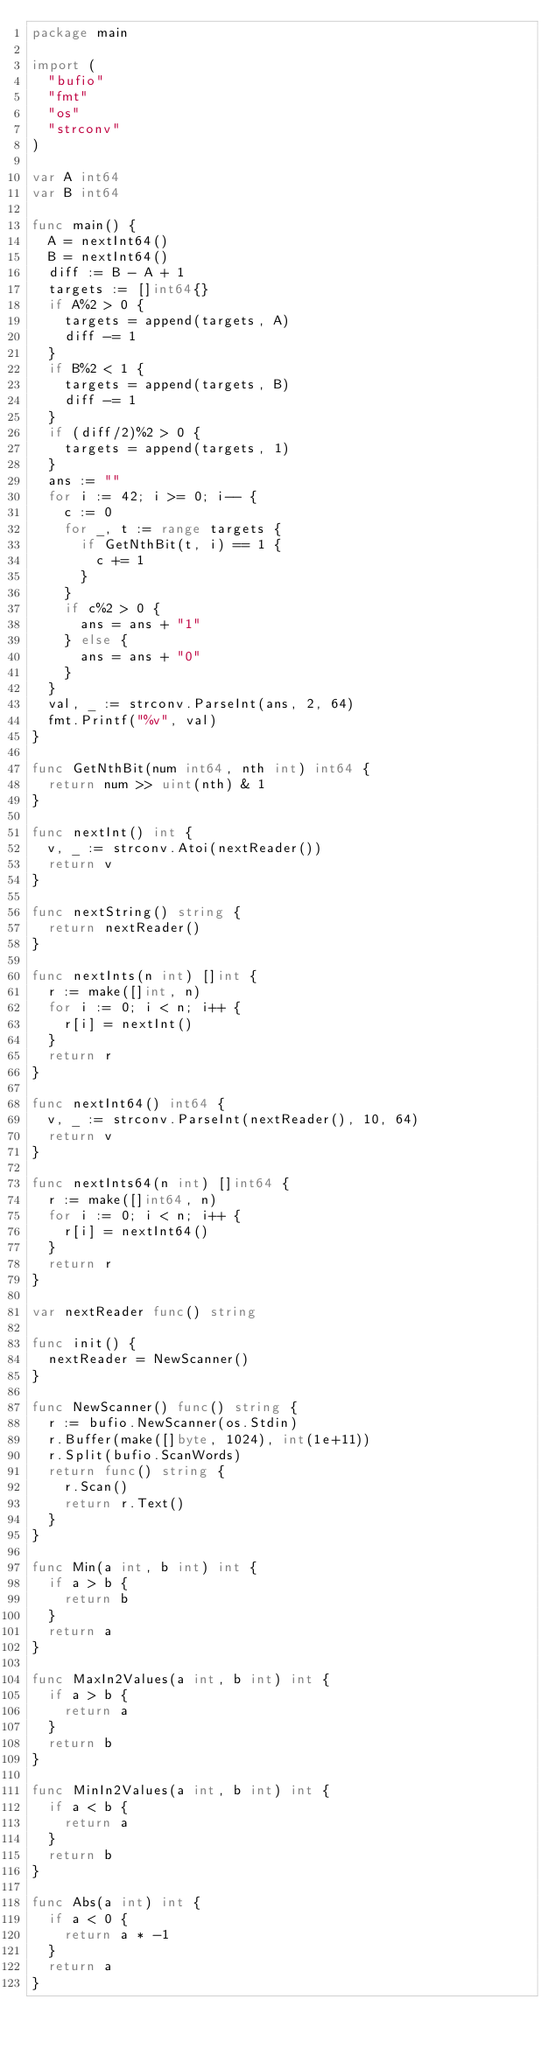<code> <loc_0><loc_0><loc_500><loc_500><_Go_>package main

import (
	"bufio"
	"fmt"
	"os"
	"strconv"
)

var A int64
var B int64

func main() {
	A = nextInt64()
	B = nextInt64()
	diff := B - A + 1
	targets := []int64{}
	if A%2 > 0 {
		targets = append(targets, A)
		diff -= 1
	}
	if B%2 < 1 {
		targets = append(targets, B)
		diff -= 1
	}
	if (diff/2)%2 > 0 {
		targets = append(targets, 1)
	}
	ans := ""
	for i := 42; i >= 0; i-- {
		c := 0
		for _, t := range targets {
			if GetNthBit(t, i) == 1 {
				c += 1
			}
		}
		if c%2 > 0 {
			ans = ans + "1"
		} else {
			ans = ans + "0"
		}
	}
	val, _ := strconv.ParseInt(ans, 2, 64)
	fmt.Printf("%v", val)
}

func GetNthBit(num int64, nth int) int64 {
	return num >> uint(nth) & 1
}

func nextInt() int {
	v, _ := strconv.Atoi(nextReader())
	return v
}

func nextString() string {
	return nextReader()
}

func nextInts(n int) []int {
	r := make([]int, n)
	for i := 0; i < n; i++ {
		r[i] = nextInt()
	}
	return r
}

func nextInt64() int64 {
	v, _ := strconv.ParseInt(nextReader(), 10, 64)
	return v
}

func nextInts64(n int) []int64 {
	r := make([]int64, n)
	for i := 0; i < n; i++ {
		r[i] = nextInt64()
	}
	return r
}

var nextReader func() string

func init() {
	nextReader = NewScanner()
}

func NewScanner() func() string {
	r := bufio.NewScanner(os.Stdin)
	r.Buffer(make([]byte, 1024), int(1e+11))
	r.Split(bufio.ScanWords)
	return func() string {
		r.Scan()
		return r.Text()
	}
}

func Min(a int, b int) int {
	if a > b {
		return b
	}
	return a
}

func MaxIn2Values(a int, b int) int {
	if a > b {
		return a
	}
	return b
}

func MinIn2Values(a int, b int) int {
	if a < b {
		return a
	}
	return b
}

func Abs(a int) int {
	if a < 0 {
		return a * -1
	}
	return a
}
</code> 